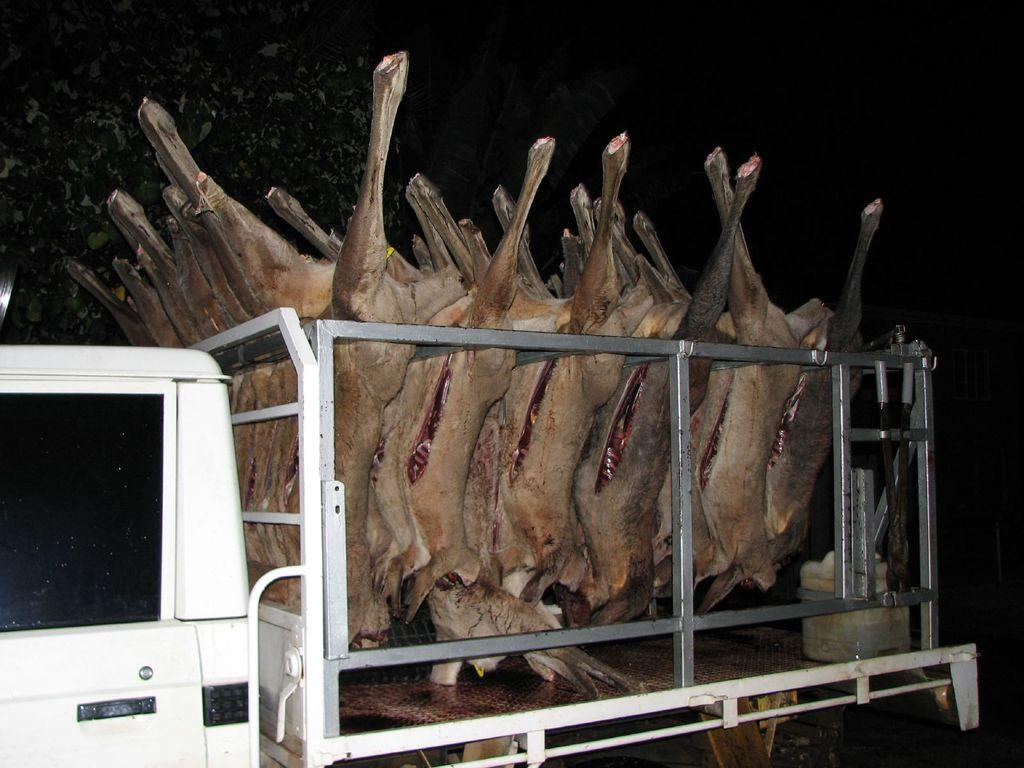What is the main subject of the image? The main subject of the image is a truck. What is the truck carrying in the image? The truck is carrying animal meat in the image. What type of feather can be seen on the truck in the image? There is no feather present on the truck in the image. What is the purpose of the cord hanging from the truck in the image? There is no cord hanging from the truck in the image. 